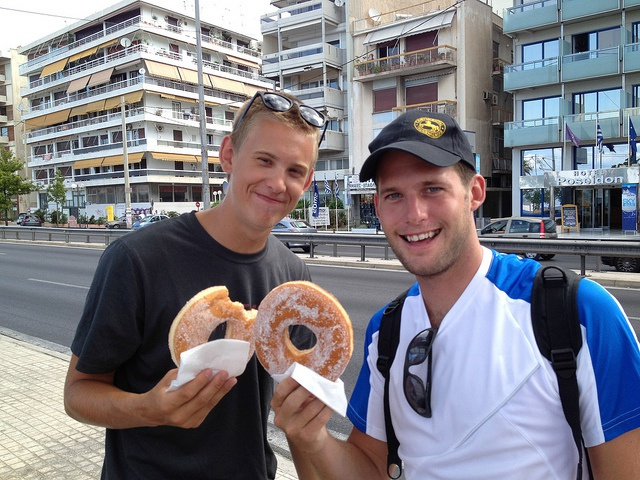Describe the objects in this image and their specific colors. I can see people in white, lavender, black, and brown tones, people in white, black, brown, and gray tones, donut in white, darkgray, salmon, tan, and brown tones, backpack in white, black, gray, and navy tones, and donut in white, tan, lightgray, and darkgray tones in this image. 